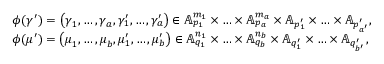<formula> <loc_0><loc_0><loc_500><loc_500>\begin{array} { r l } & { \phi ( \gamma ^ { \prime } ) = \left ( \gamma _ { 1 } , \dots , \gamma _ { a } , \gamma _ { 1 } ^ { \prime } , \dots , \gamma _ { a } ^ { \prime } \right ) \in \mathbb { A } _ { p _ { 1 } } ^ { m _ { 1 } } \times \hdots \times \mathbb { A } _ { p _ { a } } ^ { m _ { a } } \times \mathbb { A } _ { p _ { 1 } ^ { \prime } } \times \hdots \times \mathbb { A } _ { p _ { a ^ { \prime } } ^ { \prime } } , } \\ & { \phi ( \mu ^ { \prime } ) = \left ( \mu _ { 1 } , \dots , \mu _ { b } , \mu _ { 1 } ^ { \prime } , \dots , \mu _ { b } ^ { \prime } \right ) \in \mathbb { A } _ { q _ { 1 } } ^ { n _ { 1 } } \times \hdots \times \mathbb { A } _ { q _ { b } } ^ { n _ { b } } \times \mathbb { A } _ { q _ { 1 } ^ { \prime } } \times \hdots \times \mathbb { A } _ { q _ { b ^ { \prime } } ^ { \prime } } , } \end{array}</formula> 